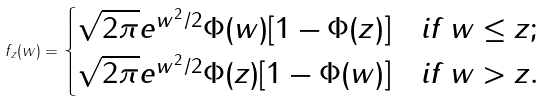Convert formula to latex. <formula><loc_0><loc_0><loc_500><loc_500>f _ { z } ( w ) = \begin{cases} \sqrt { 2 \pi } e ^ { w ^ { 2 } / 2 } \Phi ( w ) [ 1 - \Phi ( z ) ] & i f \, w \leq z ; \\ \sqrt { 2 \pi } e ^ { w ^ { 2 } / 2 } \Phi ( z ) [ 1 - \Phi ( w ) ] & i f \, w > z . \\ \end{cases}</formula> 